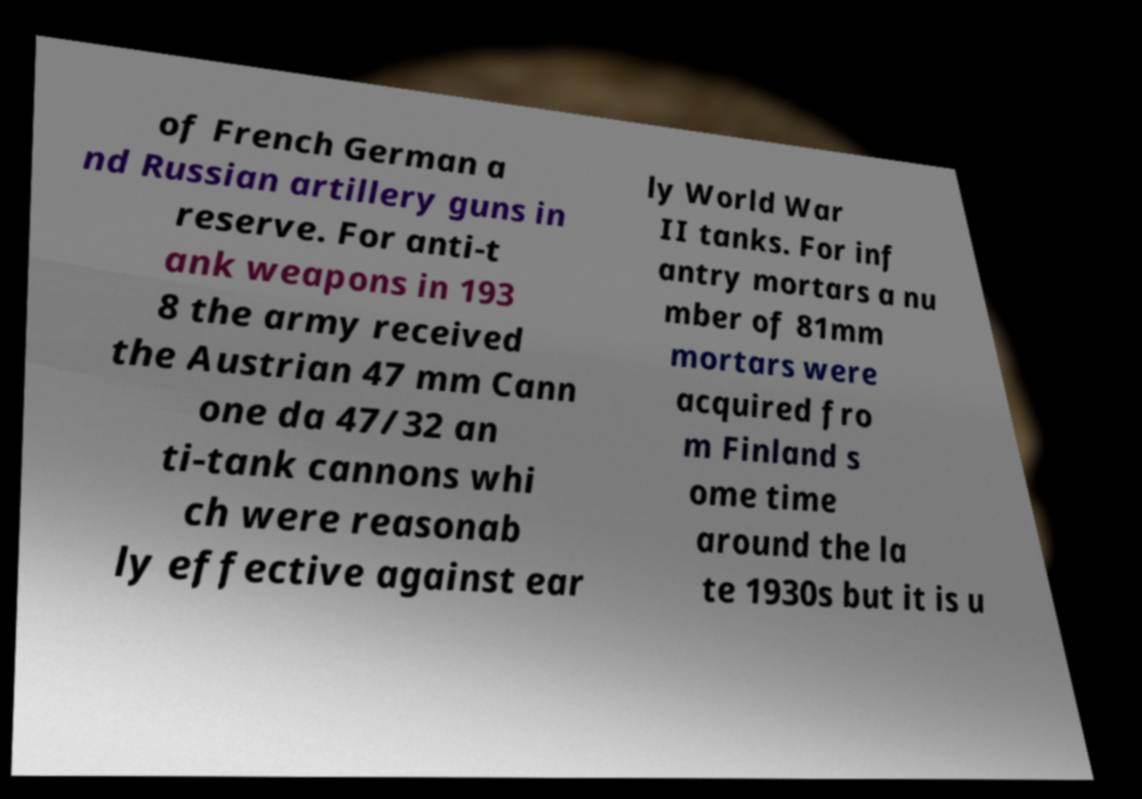Can you accurately transcribe the text from the provided image for me? of French German a nd Russian artillery guns in reserve. For anti-t ank weapons in 193 8 the army received the Austrian 47 mm Cann one da 47/32 an ti-tank cannons whi ch were reasonab ly effective against ear ly World War II tanks. For inf antry mortars a nu mber of 81mm mortars were acquired fro m Finland s ome time around the la te 1930s but it is u 